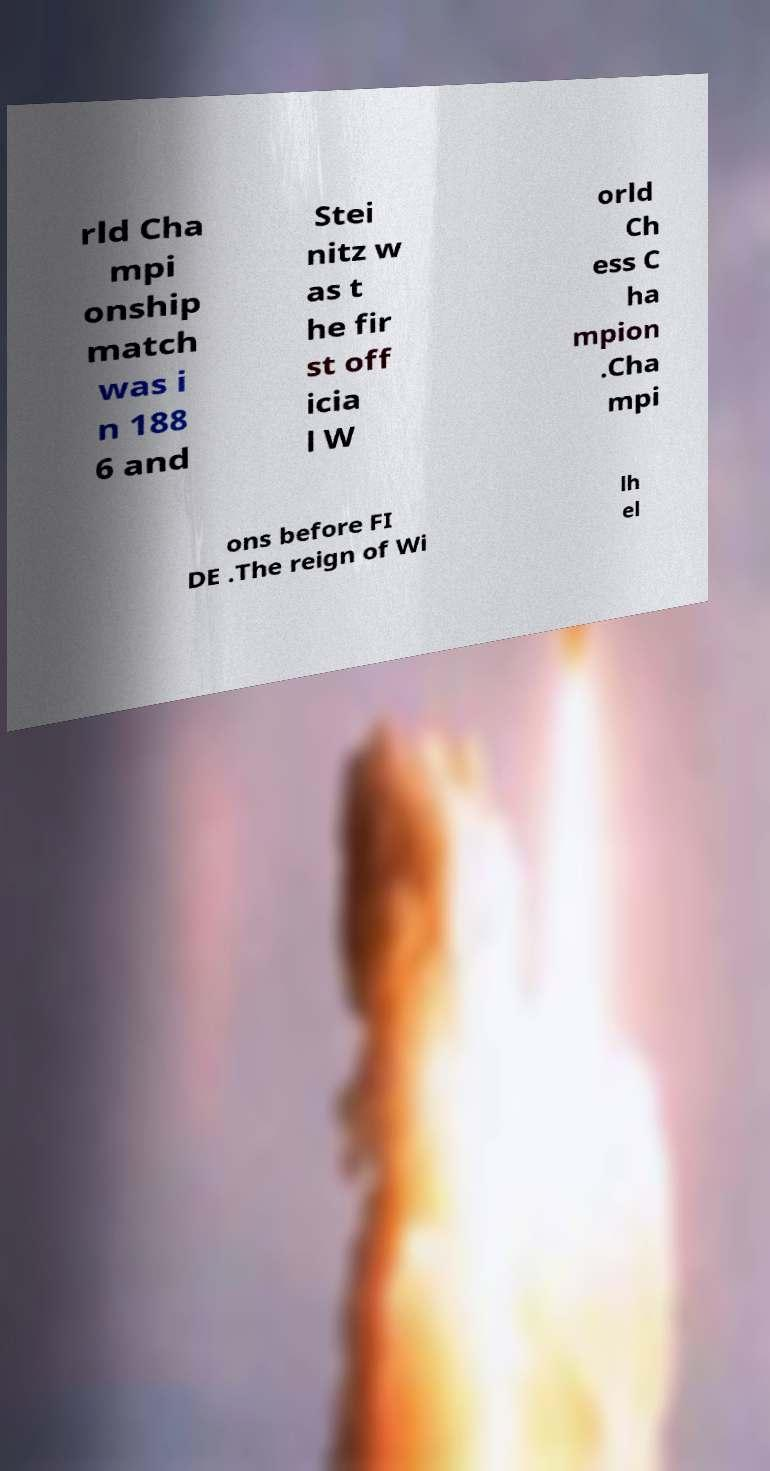Please read and relay the text visible in this image. What does it say? rld Cha mpi onship match was i n 188 6 and Stei nitz w as t he fir st off icia l W orld Ch ess C ha mpion .Cha mpi ons before FI DE .The reign of Wi lh el 